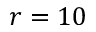<formula> <loc_0><loc_0><loc_500><loc_500>r = 1 0</formula> 